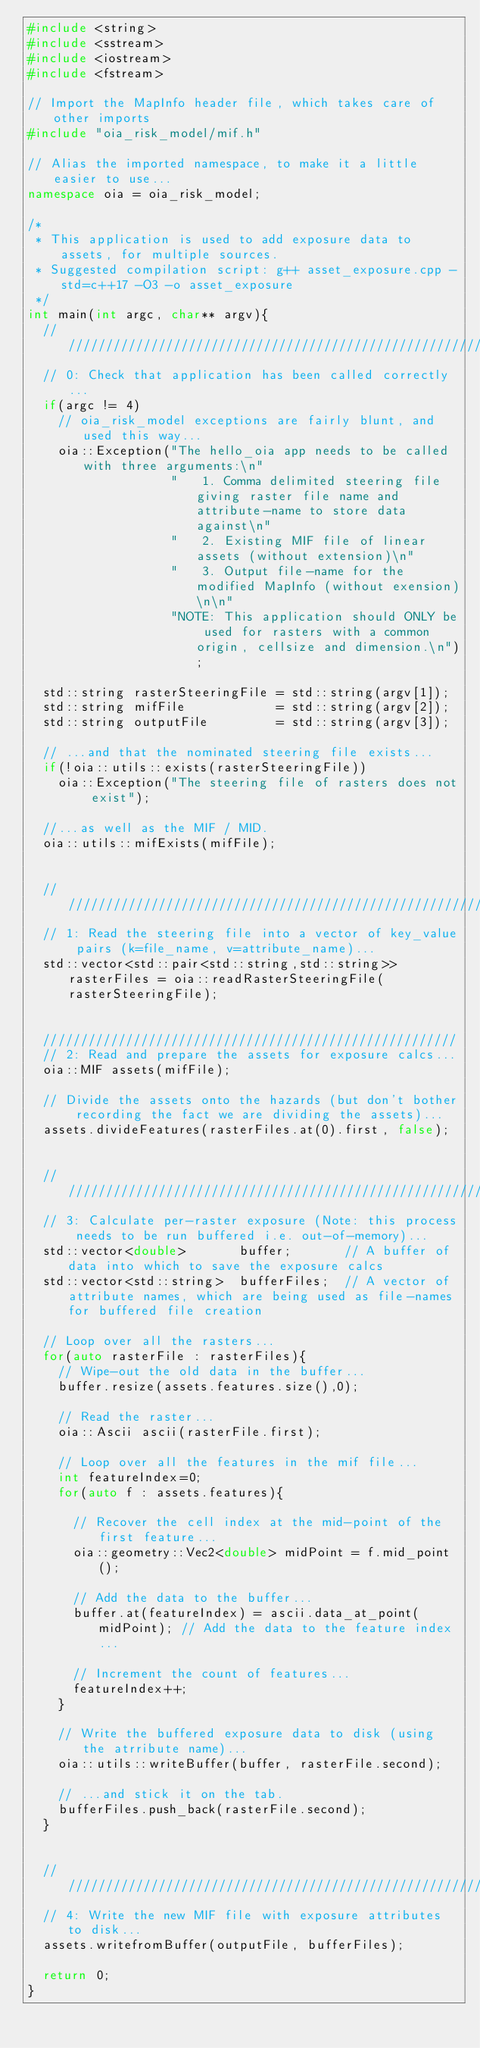<code> <loc_0><loc_0><loc_500><loc_500><_C++_>#include <string>
#include <sstream>
#include <iostream>
#include <fstream>

// Import the MapInfo header file, which takes care of other imports
#include "oia_risk_model/mif.h"

// Alias the imported namespace, to make it a little easier to use...
namespace oia = oia_risk_model;

/*
 * This application is used to add exposure data to assets, for multiple sources. 
 * Suggested compilation script: g++ asset_exposure.cpp -std=c++17 -O3 -o asset_exposure 
 */
int main(int argc, char** argv){
  /////////////////////////////////////////////////////////
  // 0: Check that application has been called correctly...
  if(argc != 4)
    // oia_risk_model exceptions are fairly blunt, and used this way...
    oia::Exception("The hello_oia app needs to be called with three arguments:\n"
                   "   1. Comma delimited steering file giving raster file name and attribute-name to store data against\n"
                   "   2. Existing MIF file of linear assets (without extension)\n"
                   "   3. Output file-name for the modified MapInfo (without exension)\n\n"
                   "NOTE: This application should ONLY be used for rasters with a common origin, cellsize and dimension.\n");

  std::string rasterSteeringFile = std::string(argv[1]);
  std::string mifFile            = std::string(argv[2]);
  std::string outputFile         = std::string(argv[3]);

  // ...and that the nominated steering file exists...
  if(!oia::utils::exists(rasterSteeringFile))
    oia::Exception("The steering file of rasters does not exist");

  //...as well as the MIF / MID.
  oia::utils::mifExists(mifFile);


  ////////////////////////////////////////////////////////////////////////////////////////////////
  // 1: Read the steering file into a vector of key_value pairs (k=file_name, v=attribute_name)...
  std::vector<std::pair<std::string,std::string>> rasterFiles = oia::readRasterSteeringFile(rasterSteeringFile);


  ///////////////////////////////////////////////////////
  // 2: Read and prepare the assets for exposure calcs...
  oia::MIF assets(mifFile);

  // Divide the assets onto the hazards (but don't bother recording the fact we are dividing the assets)...
  assets.divideFeatures(rasterFiles.at(0).first, false);


  ///////////////////////////////////////////////////////////////////////////////////////////////////////
  // 3: Calculate per-raster exposure (Note: this process needs to be run buffered i.e. out-of-memory)...
  std::vector<double>       buffer;       // A buffer of data into which to save the exposure calcs
  std::vector<std::string>  bufferFiles;  // A vector of attribute names, which are being used as file-names for buffered file creation

  // Loop over all the rasters...
  for(auto rasterFile : rasterFiles){
    // Wipe-out the old data in the buffer...
    buffer.resize(assets.features.size(),0);

    // Read the raster...
    oia::Ascii ascii(rasterFile.first);

    // Loop over all the features in the mif file...
    int featureIndex=0;
    for(auto f : assets.features){

      // Recover the cell index at the mid-point of the first feature...
      oia::geometry::Vec2<double> midPoint = f.mid_point();

      // Add the data to the buffer...
      buffer.at(featureIndex) = ascii.data_at_point(midPoint); // Add the data to the feature index...

      // Increment the count of features...
      featureIndex++;
    }

    // Write the buffered exposure data to disk (using the atrribute name)...
    oia::utils::writeBuffer(buffer, rasterFile.second);

    // ...and stick it on the tab.
    bufferFiles.push_back(rasterFile.second);
  }


  ////////////////////////////////////////////////////////////////
  // 4: Write the new MIF file with exposure attributes to disk...
  assets.writefromBuffer(outputFile, bufferFiles);

  return 0;
}</code> 